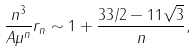Convert formula to latex. <formula><loc_0><loc_0><loc_500><loc_500>\frac { n ^ { 3 } } { A \mu ^ { n } } r _ { n } & \sim 1 + \frac { 3 3 / 2 - 1 1 \sqrt { 3 } } { n } ,</formula> 